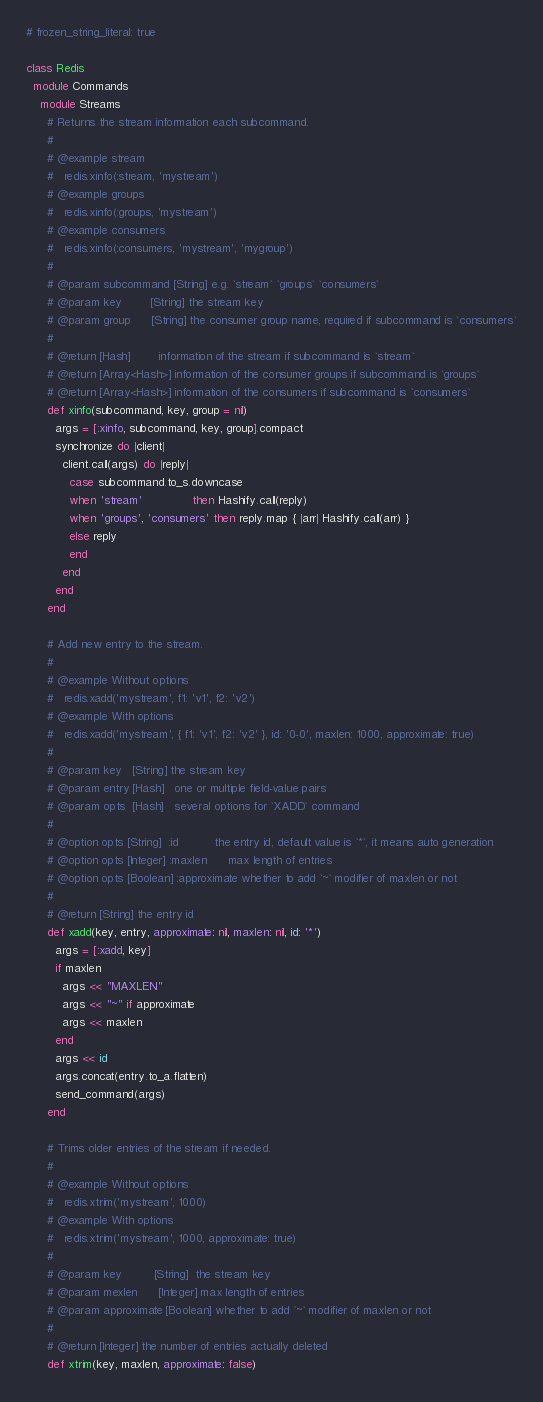Convert code to text. <code><loc_0><loc_0><loc_500><loc_500><_Ruby_># frozen_string_literal: true

class Redis
  module Commands
    module Streams
      # Returns the stream information each subcommand.
      #
      # @example stream
      #   redis.xinfo(:stream, 'mystream')
      # @example groups
      #   redis.xinfo(:groups, 'mystream')
      # @example consumers
      #   redis.xinfo(:consumers, 'mystream', 'mygroup')
      #
      # @param subcommand [String] e.g. `stream` `groups` `consumers`
      # @param key        [String] the stream key
      # @param group      [String] the consumer group name, required if subcommand is `consumers`
      #
      # @return [Hash]        information of the stream if subcommand is `stream`
      # @return [Array<Hash>] information of the consumer groups if subcommand is `groups`
      # @return [Array<Hash>] information of the consumers if subcommand is `consumers`
      def xinfo(subcommand, key, group = nil)
        args = [:xinfo, subcommand, key, group].compact
        synchronize do |client|
          client.call(args) do |reply|
            case subcommand.to_s.downcase
            when 'stream'              then Hashify.call(reply)
            when 'groups', 'consumers' then reply.map { |arr| Hashify.call(arr) }
            else reply
            end
          end
        end
      end

      # Add new entry to the stream.
      #
      # @example Without options
      #   redis.xadd('mystream', f1: 'v1', f2: 'v2')
      # @example With options
      #   redis.xadd('mystream', { f1: 'v1', f2: 'v2' }, id: '0-0', maxlen: 1000, approximate: true)
      #
      # @param key   [String] the stream key
      # @param entry [Hash]   one or multiple field-value pairs
      # @param opts  [Hash]   several options for `XADD` command
      #
      # @option opts [String]  :id          the entry id, default value is `*`, it means auto generation
      # @option opts [Integer] :maxlen      max length of entries
      # @option opts [Boolean] :approximate whether to add `~` modifier of maxlen or not
      #
      # @return [String] the entry id
      def xadd(key, entry, approximate: nil, maxlen: nil, id: '*')
        args = [:xadd, key]
        if maxlen
          args << "MAXLEN"
          args << "~" if approximate
          args << maxlen
        end
        args << id
        args.concat(entry.to_a.flatten)
        send_command(args)
      end

      # Trims older entries of the stream if needed.
      #
      # @example Without options
      #   redis.xtrim('mystream', 1000)
      # @example With options
      #   redis.xtrim('mystream', 1000, approximate: true)
      #
      # @param key         [String]  the stream key
      # @param mexlen      [Integer] max length of entries
      # @param approximate [Boolean] whether to add `~` modifier of maxlen or not
      #
      # @return [Integer] the number of entries actually deleted
      def xtrim(key, maxlen, approximate: false)</code> 